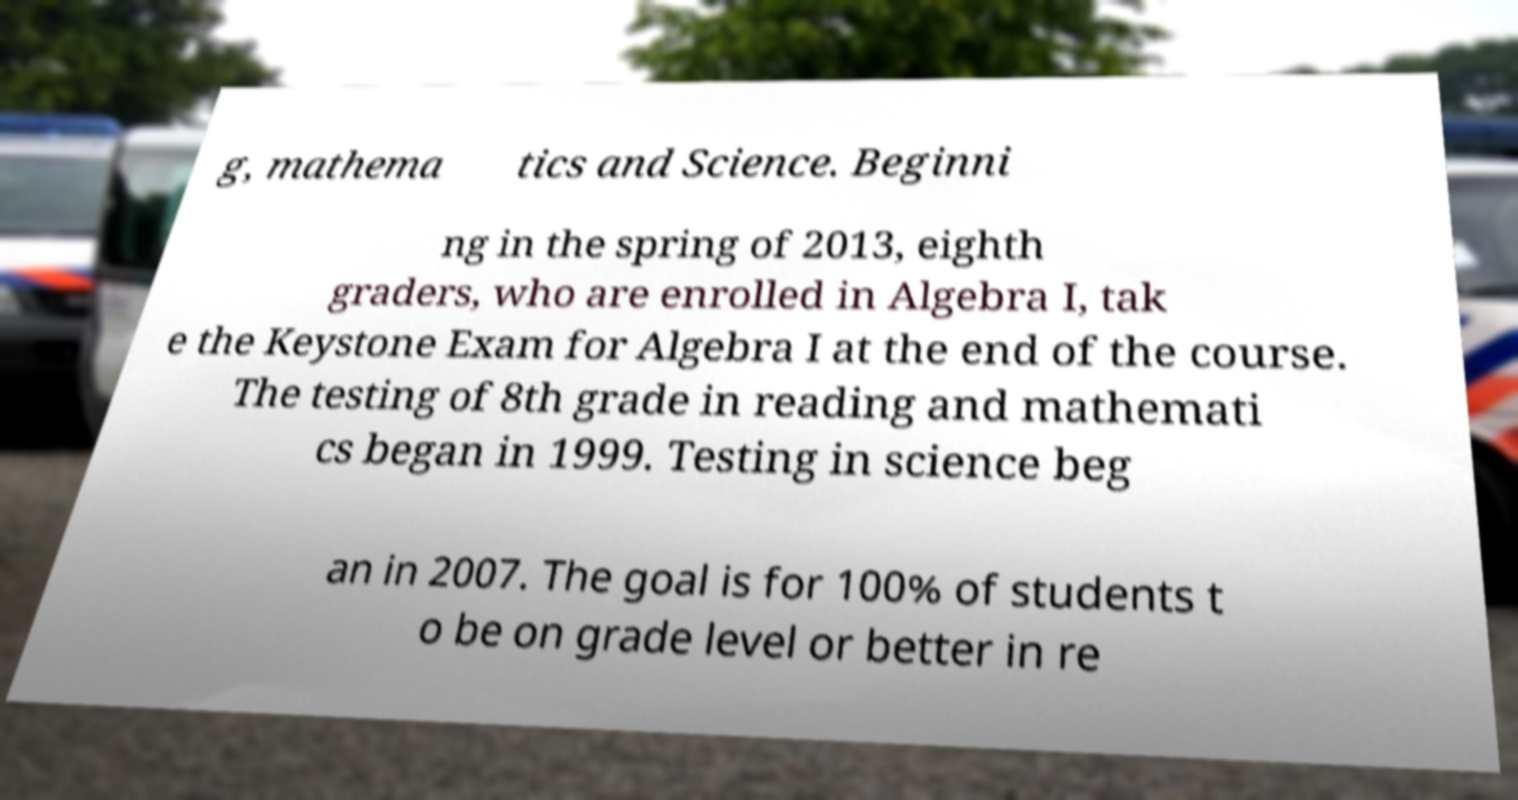There's text embedded in this image that I need extracted. Can you transcribe it verbatim? g, mathema tics and Science. Beginni ng in the spring of 2013, eighth graders, who are enrolled in Algebra I, tak e the Keystone Exam for Algebra I at the end of the course. The testing of 8th grade in reading and mathemati cs began in 1999. Testing in science beg an in 2007. The goal is for 100% of students t o be on grade level or better in re 